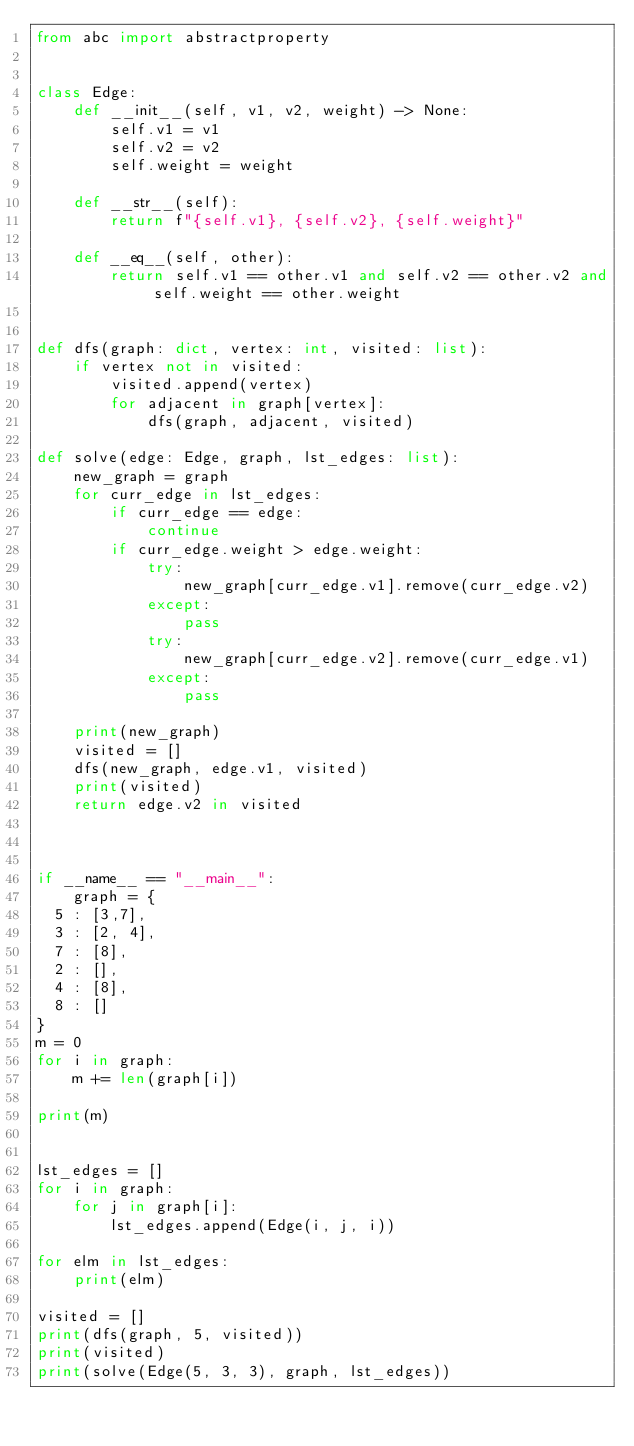Convert code to text. <code><loc_0><loc_0><loc_500><loc_500><_Python_>from abc import abstractproperty


class Edge:
    def __init__(self, v1, v2, weight) -> None:
        self.v1 = v1
        self.v2 = v2
        self.weight = weight
    
    def __str__(self):
        return f"{self.v1}, {self.v2}, {self.weight}"

    def __eq__(self, other):
        return self.v1 == other.v1 and self.v2 == other.v2 and self.weight == other.weight


def dfs(graph: dict, vertex: int, visited: list):
    if vertex not in visited:
        visited.append(vertex)
        for adjacent in graph[vertex]:
            dfs(graph, adjacent, visited)

def solve(edge: Edge, graph, lst_edges: list):
    new_graph = graph
    for curr_edge in lst_edges:
        if curr_edge == edge:
            continue
        if curr_edge.weight > edge.weight:
            try:
                new_graph[curr_edge.v1].remove(curr_edge.v2)
            except:
                pass
            try:
                new_graph[curr_edge.v2].remove(curr_edge.v1)
            except:
                pass
    
    print(new_graph)
    visited = []
    dfs(new_graph, edge.v1, visited)
    print(visited)
    return edge.v2 in visited

    

if __name__ == "__main__":
    graph = {
  5 : [3,7],
  3 : [2, 4],
  7 : [8],
  2 : [],
  4 : [8],
  8 : []
}
m = 0
for i in graph:
    m += len(graph[i])

print(m)


lst_edges = []
for i in graph:
    for j in graph[i]:
        lst_edges.append(Edge(i, j, i))

for elm in lst_edges:
    print(elm)

visited = []
print(dfs(graph, 5, visited))
print(visited)
print(solve(Edge(5, 3, 3), graph, lst_edges))
</code> 